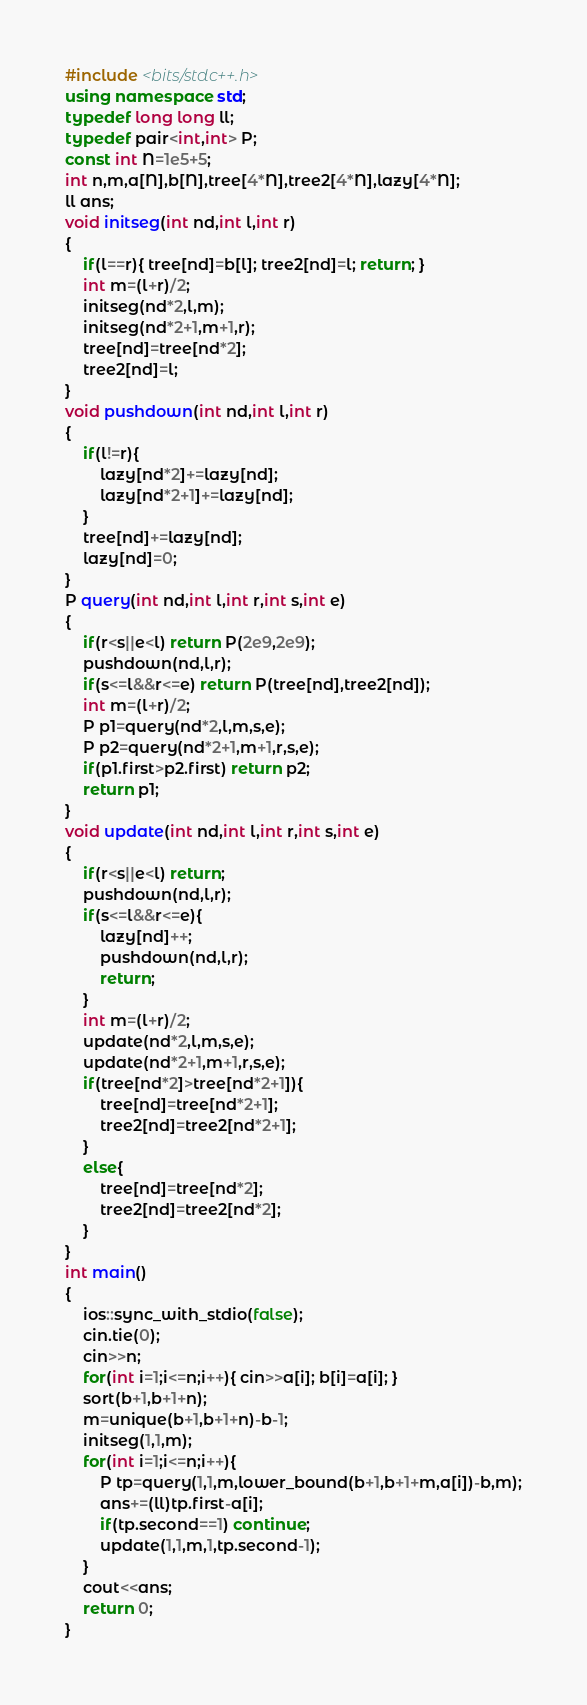<code> <loc_0><loc_0><loc_500><loc_500><_C++_>#include <bits/stdc++.h>
using namespace std;
typedef long long ll;
typedef pair<int,int> P;
const int N=1e5+5;
int n,m,a[N],b[N],tree[4*N],tree2[4*N],lazy[4*N];
ll ans;
void initseg(int nd,int l,int r)
{
    if(l==r){ tree[nd]=b[l]; tree2[nd]=l; return; }
    int m=(l+r)/2;
    initseg(nd*2,l,m);
    initseg(nd*2+1,m+1,r);
    tree[nd]=tree[nd*2];
    tree2[nd]=l;
}
void pushdown(int nd,int l,int r)
{
    if(l!=r){
        lazy[nd*2]+=lazy[nd];
        lazy[nd*2+1]+=lazy[nd];
    }
    tree[nd]+=lazy[nd];
    lazy[nd]=0;
}
P query(int nd,int l,int r,int s,int e)
{
    if(r<s||e<l) return P(2e9,2e9);
    pushdown(nd,l,r);
    if(s<=l&&r<=e) return P(tree[nd],tree2[nd]);
    int m=(l+r)/2;
    P p1=query(nd*2,l,m,s,e);
    P p2=query(nd*2+1,m+1,r,s,e);
    if(p1.first>p2.first) return p2;
    return p1;
}
void update(int nd,int l,int r,int s,int e)
{
    if(r<s||e<l) return;
    pushdown(nd,l,r);
    if(s<=l&&r<=e){
        lazy[nd]++;
        pushdown(nd,l,r);
        return;
    }
    int m=(l+r)/2;
    update(nd*2,l,m,s,e);
    update(nd*2+1,m+1,r,s,e);
    if(tree[nd*2]>tree[nd*2+1]){
        tree[nd]=tree[nd*2+1];
        tree2[nd]=tree2[nd*2+1];
    }
    else{
        tree[nd]=tree[nd*2];
        tree2[nd]=tree2[nd*2];
    }
}
int main()
{
    ios::sync_with_stdio(false);
    cin.tie(0);
    cin>>n;
    for(int i=1;i<=n;i++){ cin>>a[i]; b[i]=a[i]; }
    sort(b+1,b+1+n);
    m=unique(b+1,b+1+n)-b-1;
    initseg(1,1,m);
    for(int i=1;i<=n;i++){
        P tp=query(1,1,m,lower_bound(b+1,b+1+m,a[i])-b,m);
        ans+=(ll)tp.first-a[i];
        if(tp.second==1) continue;
        update(1,1,m,1,tp.second-1);
    }
    cout<<ans;
    return 0;
}</code> 